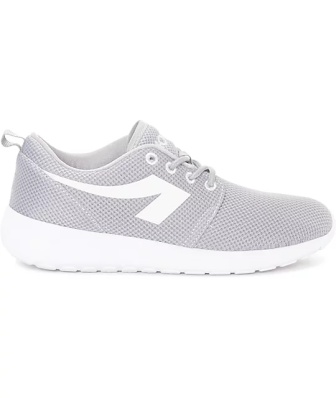Can you describe the potential target market for this type of sneaker? This sneaker would likely appeal to a market segment that values both style and comfort. Young adults and professionals who seek a versatile shoe for multiple contexts, from casual offices to weekend outings, could find this sneaker particularly attractive. Its clean and modern aesthetic suggests it could resonate with those who prefer streamlined and functional fashion. Additionally, due to its simplistic design, the shoe might attract individuals who favor minimalism in their wardrobe. 